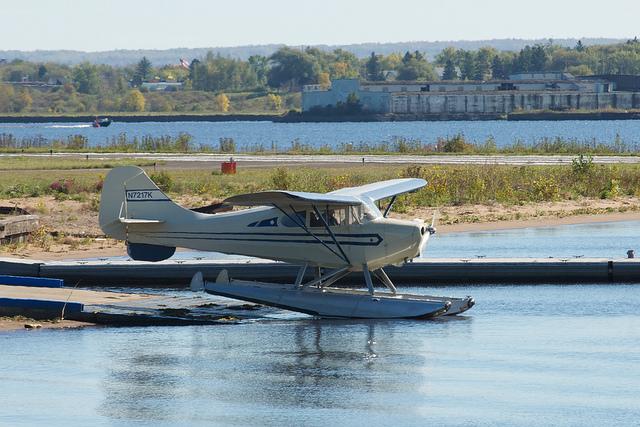What is under the plane?
Short answer required. Water. How many planes are on the water?
Write a very short answer. 1. Can this plane land on water?
Keep it brief. Yes. 